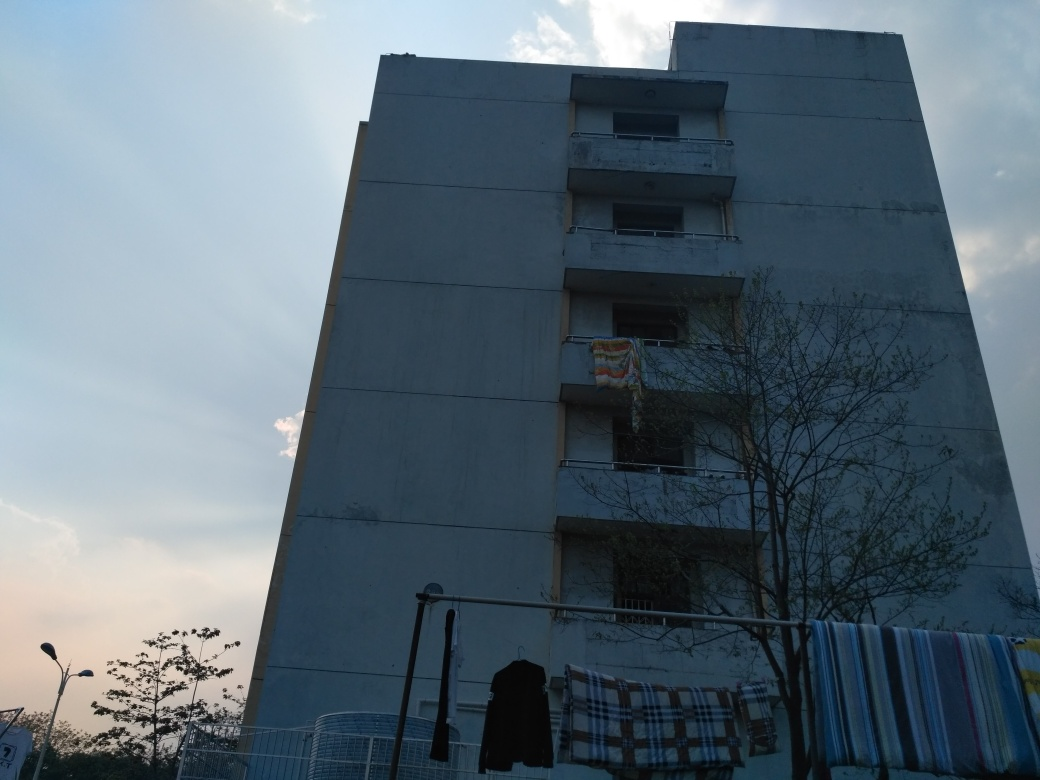What time of day does this photo appear to be taken? Based on the long shadows and the quality of ambient light, the photo seems to be taken during the early morning or late afternoon, potentially during the 'golden hour' which is a short period after sunrise or before sunset. 